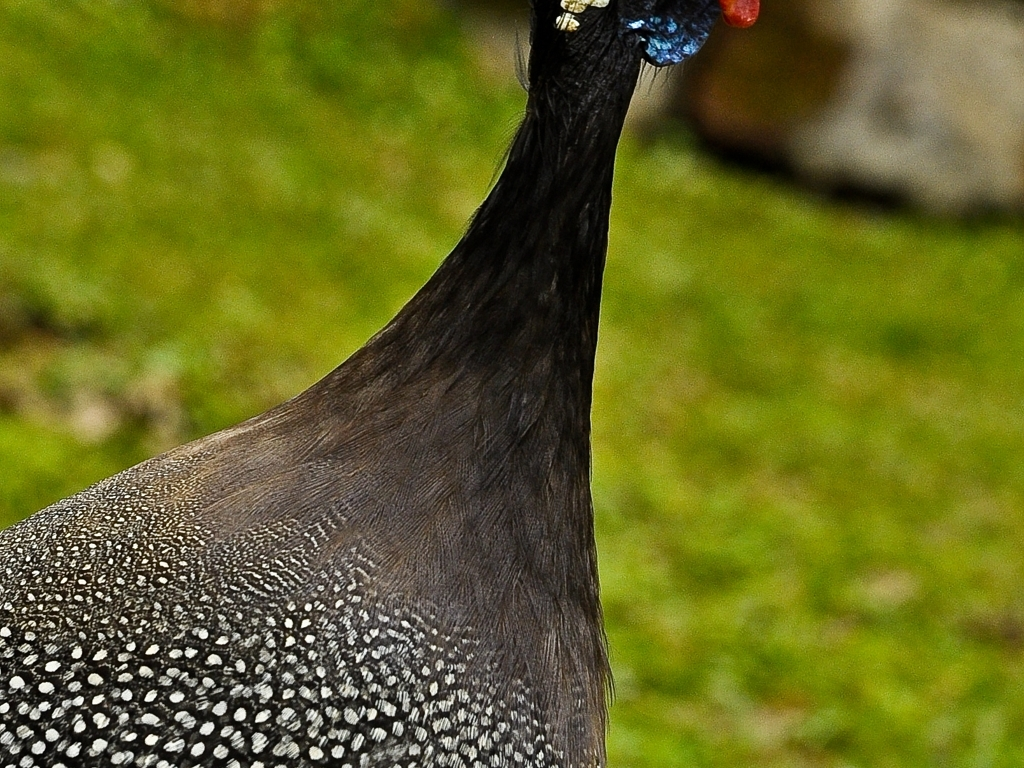Based on the peacock's physical characteristics visible in the image, can you infer anything about its health or age? The peacock's physical condition looks excellent, with a vibrant coloration and no apparent signs of malnutrition or disease. The feathers look well-maintained and not tattered, indicating good health. Although it's not possible to precisely determine the age from this image, the full development of the plumage and vivid colors might suggest that it is an adult peacock in its prime. 